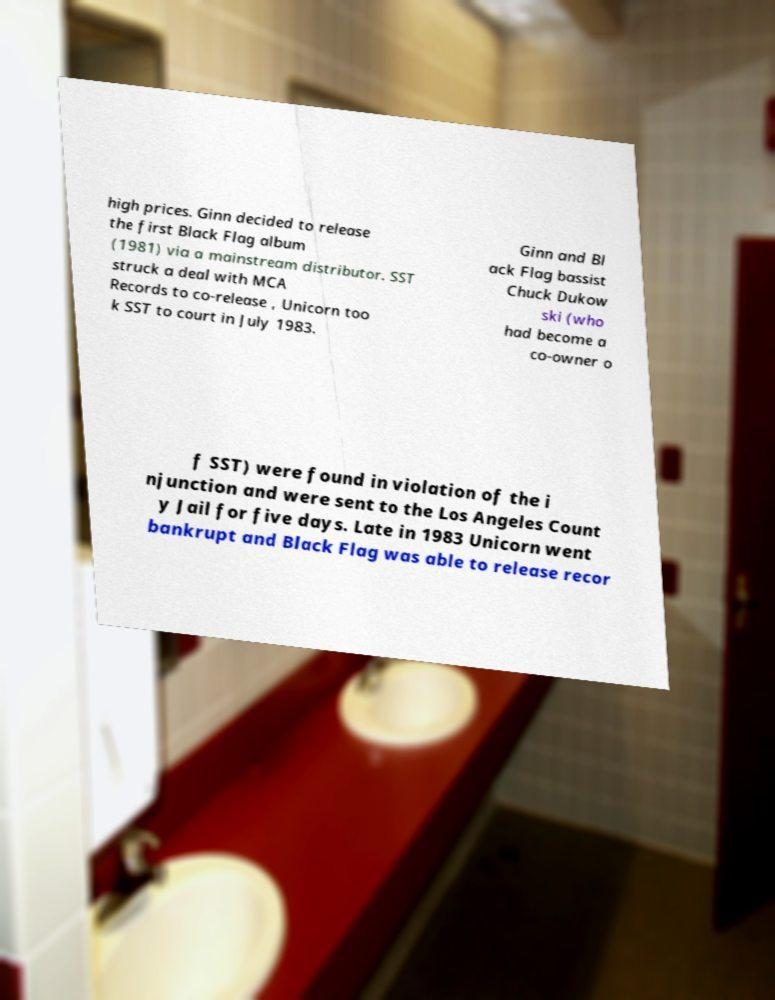Could you extract and type out the text from this image? high prices. Ginn decided to release the first Black Flag album (1981) via a mainstream distributor. SST struck a deal with MCA Records to co-release , Unicorn too k SST to court in July 1983. Ginn and Bl ack Flag bassist Chuck Dukow ski (who had become a co-owner o f SST) were found in violation of the i njunction and were sent to the Los Angeles Count y Jail for five days. Late in 1983 Unicorn went bankrupt and Black Flag was able to release recor 